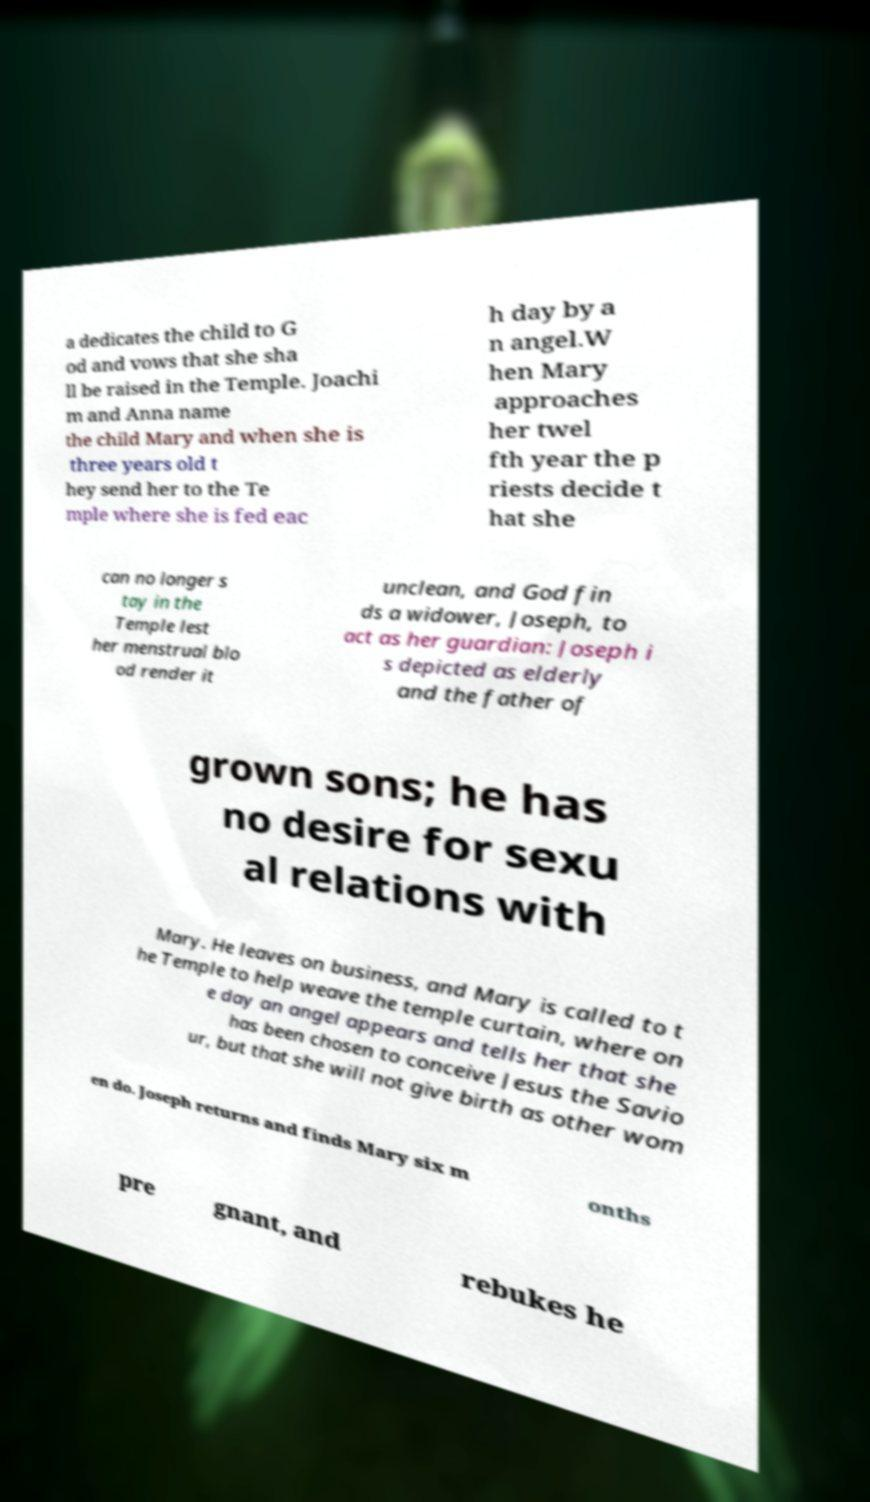Can you accurately transcribe the text from the provided image for me? a dedicates the child to G od and vows that she sha ll be raised in the Temple. Joachi m and Anna name the child Mary and when she is three years old t hey send her to the Te mple where she is fed eac h day by a n angel.W hen Mary approaches her twel fth year the p riests decide t hat she can no longer s tay in the Temple lest her menstrual blo od render it unclean, and God fin ds a widower, Joseph, to act as her guardian: Joseph i s depicted as elderly and the father of grown sons; he has no desire for sexu al relations with Mary. He leaves on business, and Mary is called to t he Temple to help weave the temple curtain, where on e day an angel appears and tells her that she has been chosen to conceive Jesus the Savio ur, but that she will not give birth as other wom en do. Joseph returns and finds Mary six m onths pre gnant, and rebukes he 